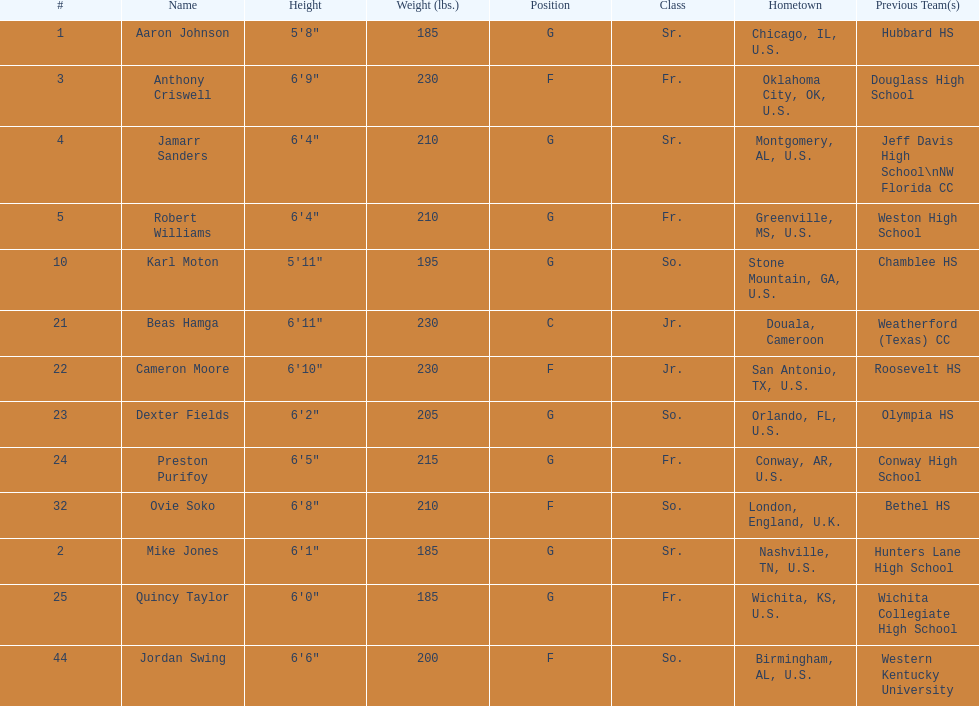How many players come from alabama? 2. 